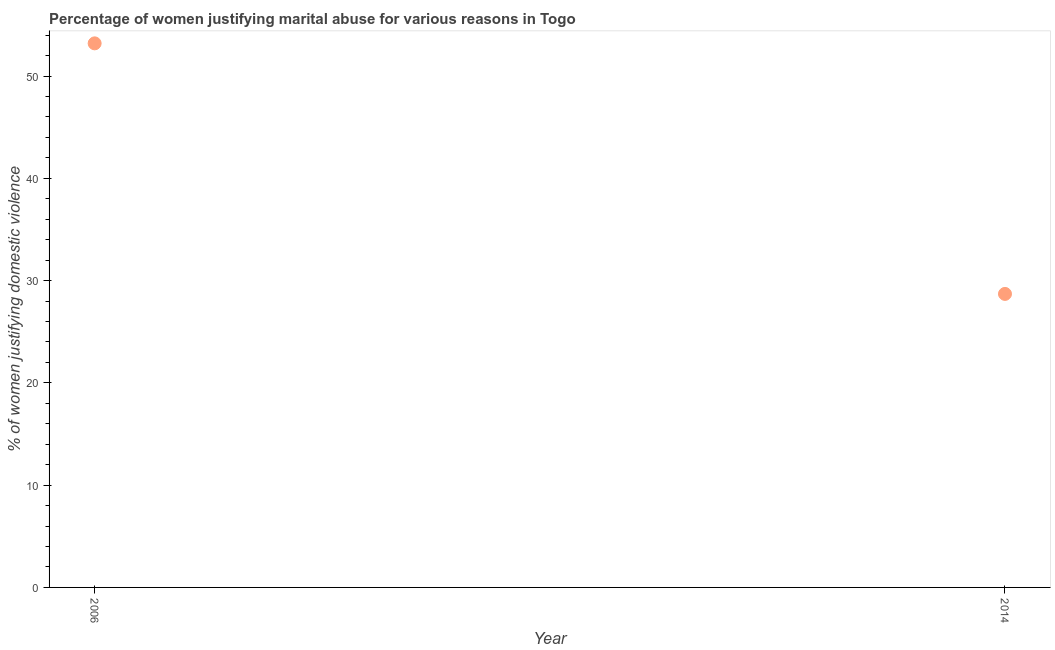What is the percentage of women justifying marital abuse in 2006?
Your answer should be very brief. 53.2. Across all years, what is the maximum percentage of women justifying marital abuse?
Make the answer very short. 53.2. Across all years, what is the minimum percentage of women justifying marital abuse?
Offer a terse response. 28.7. What is the sum of the percentage of women justifying marital abuse?
Provide a succinct answer. 81.9. What is the difference between the percentage of women justifying marital abuse in 2006 and 2014?
Provide a short and direct response. 24.5. What is the average percentage of women justifying marital abuse per year?
Keep it short and to the point. 40.95. What is the median percentage of women justifying marital abuse?
Provide a short and direct response. 40.95. In how many years, is the percentage of women justifying marital abuse greater than 6 %?
Your answer should be compact. 2. Do a majority of the years between 2014 and 2006 (inclusive) have percentage of women justifying marital abuse greater than 32 %?
Give a very brief answer. No. What is the ratio of the percentage of women justifying marital abuse in 2006 to that in 2014?
Provide a short and direct response. 1.85. How many years are there in the graph?
Ensure brevity in your answer.  2. Does the graph contain any zero values?
Ensure brevity in your answer.  No. What is the title of the graph?
Make the answer very short. Percentage of women justifying marital abuse for various reasons in Togo. What is the label or title of the Y-axis?
Make the answer very short. % of women justifying domestic violence. What is the % of women justifying domestic violence in 2006?
Make the answer very short. 53.2. What is the % of women justifying domestic violence in 2014?
Offer a very short reply. 28.7. What is the difference between the % of women justifying domestic violence in 2006 and 2014?
Provide a succinct answer. 24.5. What is the ratio of the % of women justifying domestic violence in 2006 to that in 2014?
Ensure brevity in your answer.  1.85. 